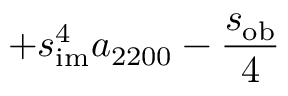Convert formula to latex. <formula><loc_0><loc_0><loc_500><loc_500>+ s _ { i m } ^ { 4 } a _ { 2 2 0 0 } - \frac { s _ { o b } } { 4 }</formula> 